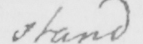What is written in this line of handwriting? stand 